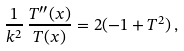<formula> <loc_0><loc_0><loc_500><loc_500>\frac { 1 } { k ^ { 2 } } \, \frac { T ^ { \prime \prime } ( x ) } { T ( x ) } = 2 ( - 1 + T ^ { 2 } ) \, ,</formula> 